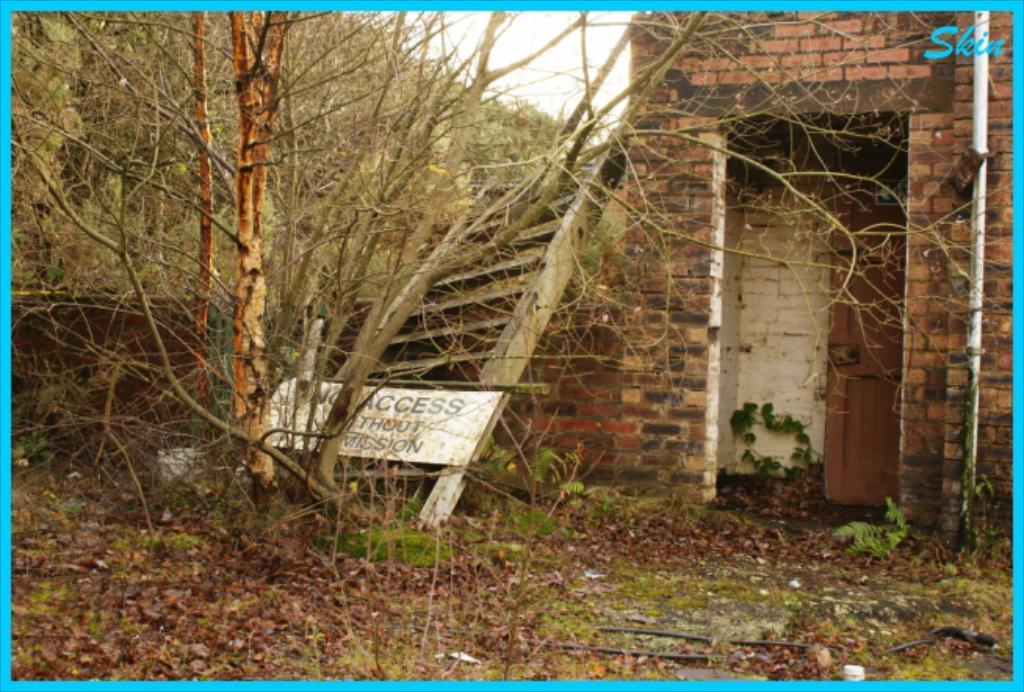What is the sign warning us of?
Ensure brevity in your answer.  No access. 